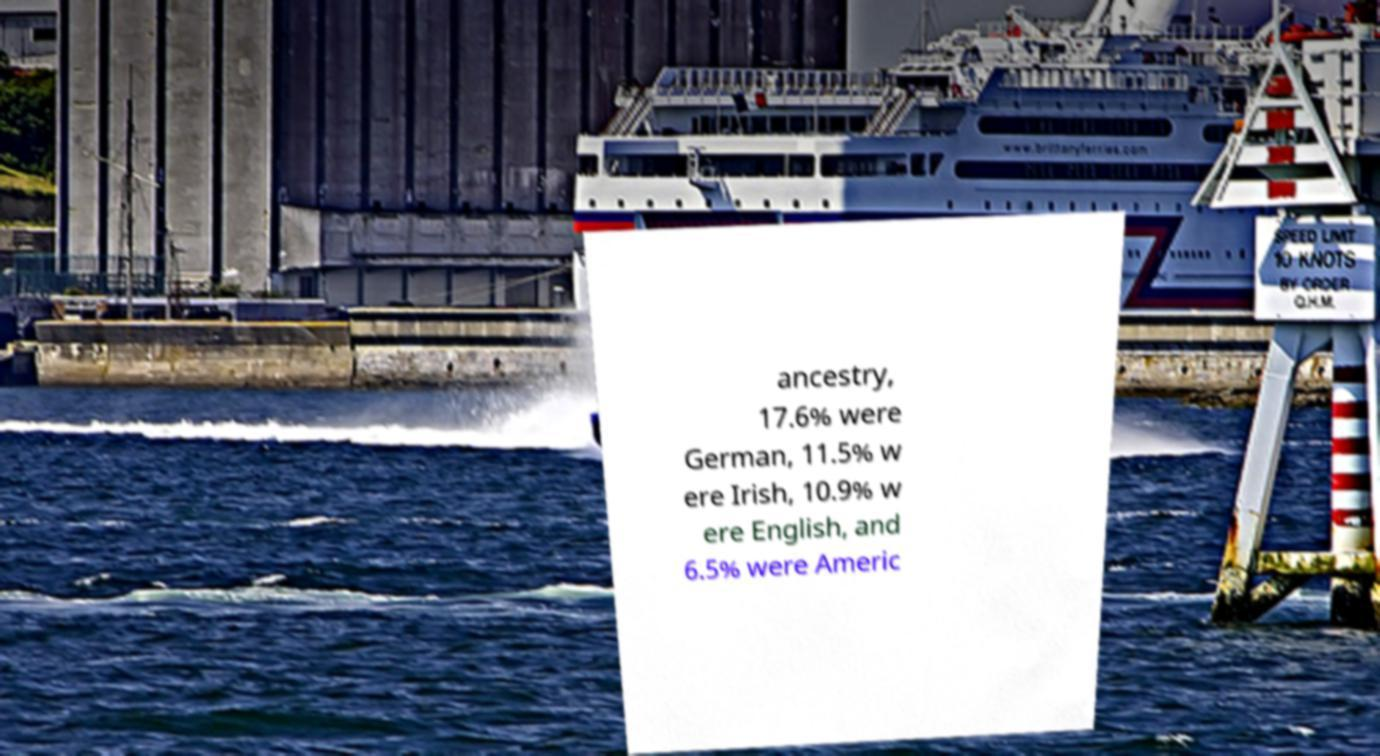Can you accurately transcribe the text from the provided image for me? ancestry, 17.6% were German, 11.5% w ere Irish, 10.9% w ere English, and 6.5% were Americ 